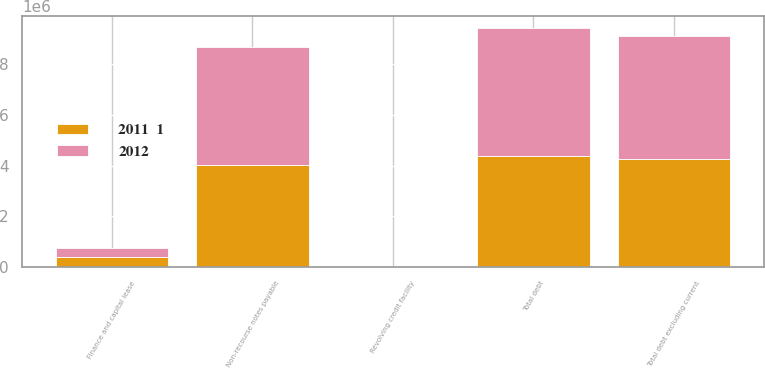<chart> <loc_0><loc_0><loc_500><loc_500><stacked_bar_chart><ecel><fcel>Revolving credit facility<fcel>Finance and capital lease<fcel>Non-recourse notes payable<fcel>Total debt<fcel>Total debt excluding current<nl><fcel>2012<fcel>943<fcel>367674<fcel>4.68409e+06<fcel>5.05271e+06<fcel>4.86332e+06<nl><fcel>2011  1<fcel>1002<fcel>380234<fcel>4.01366e+06<fcel>4.3949e+06<fcel>4.24876e+06<nl></chart> 